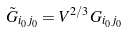Convert formula to latex. <formula><loc_0><loc_0><loc_500><loc_500>\tilde { G } _ { i _ { 0 } j _ { 0 } } = V ^ { 2 / 3 } G _ { i _ { 0 } j _ { 0 } }</formula> 